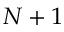<formula> <loc_0><loc_0><loc_500><loc_500>N + 1</formula> 